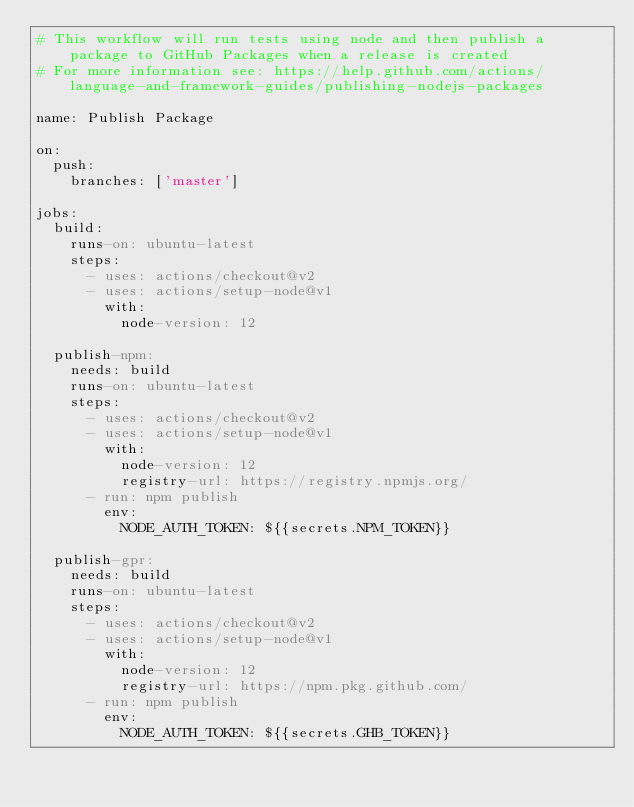<code> <loc_0><loc_0><loc_500><loc_500><_YAML_># This workflow will run tests using node and then publish a package to GitHub Packages when a release is created
# For more information see: https://help.github.com/actions/language-and-framework-guides/publishing-nodejs-packages

name: Publish Package

on:
  push:
    branches: ['master']

jobs:
  build:
    runs-on: ubuntu-latest
    steps:
      - uses: actions/checkout@v2
      - uses: actions/setup-node@v1
        with:
          node-version: 12

  publish-npm:
    needs: build
    runs-on: ubuntu-latest
    steps:
      - uses: actions/checkout@v2
      - uses: actions/setup-node@v1
        with:
          node-version: 12
          registry-url: https://registry.npmjs.org/
      - run: npm publish
        env:
          NODE_AUTH_TOKEN: ${{secrets.NPM_TOKEN}}

  publish-gpr:
    needs: build
    runs-on: ubuntu-latest
    steps:
      - uses: actions/checkout@v2
      - uses: actions/setup-node@v1
        with:
          node-version: 12
          registry-url: https://npm.pkg.github.com/
      - run: npm publish
        env:
          NODE_AUTH_TOKEN: ${{secrets.GHB_TOKEN}}
</code> 